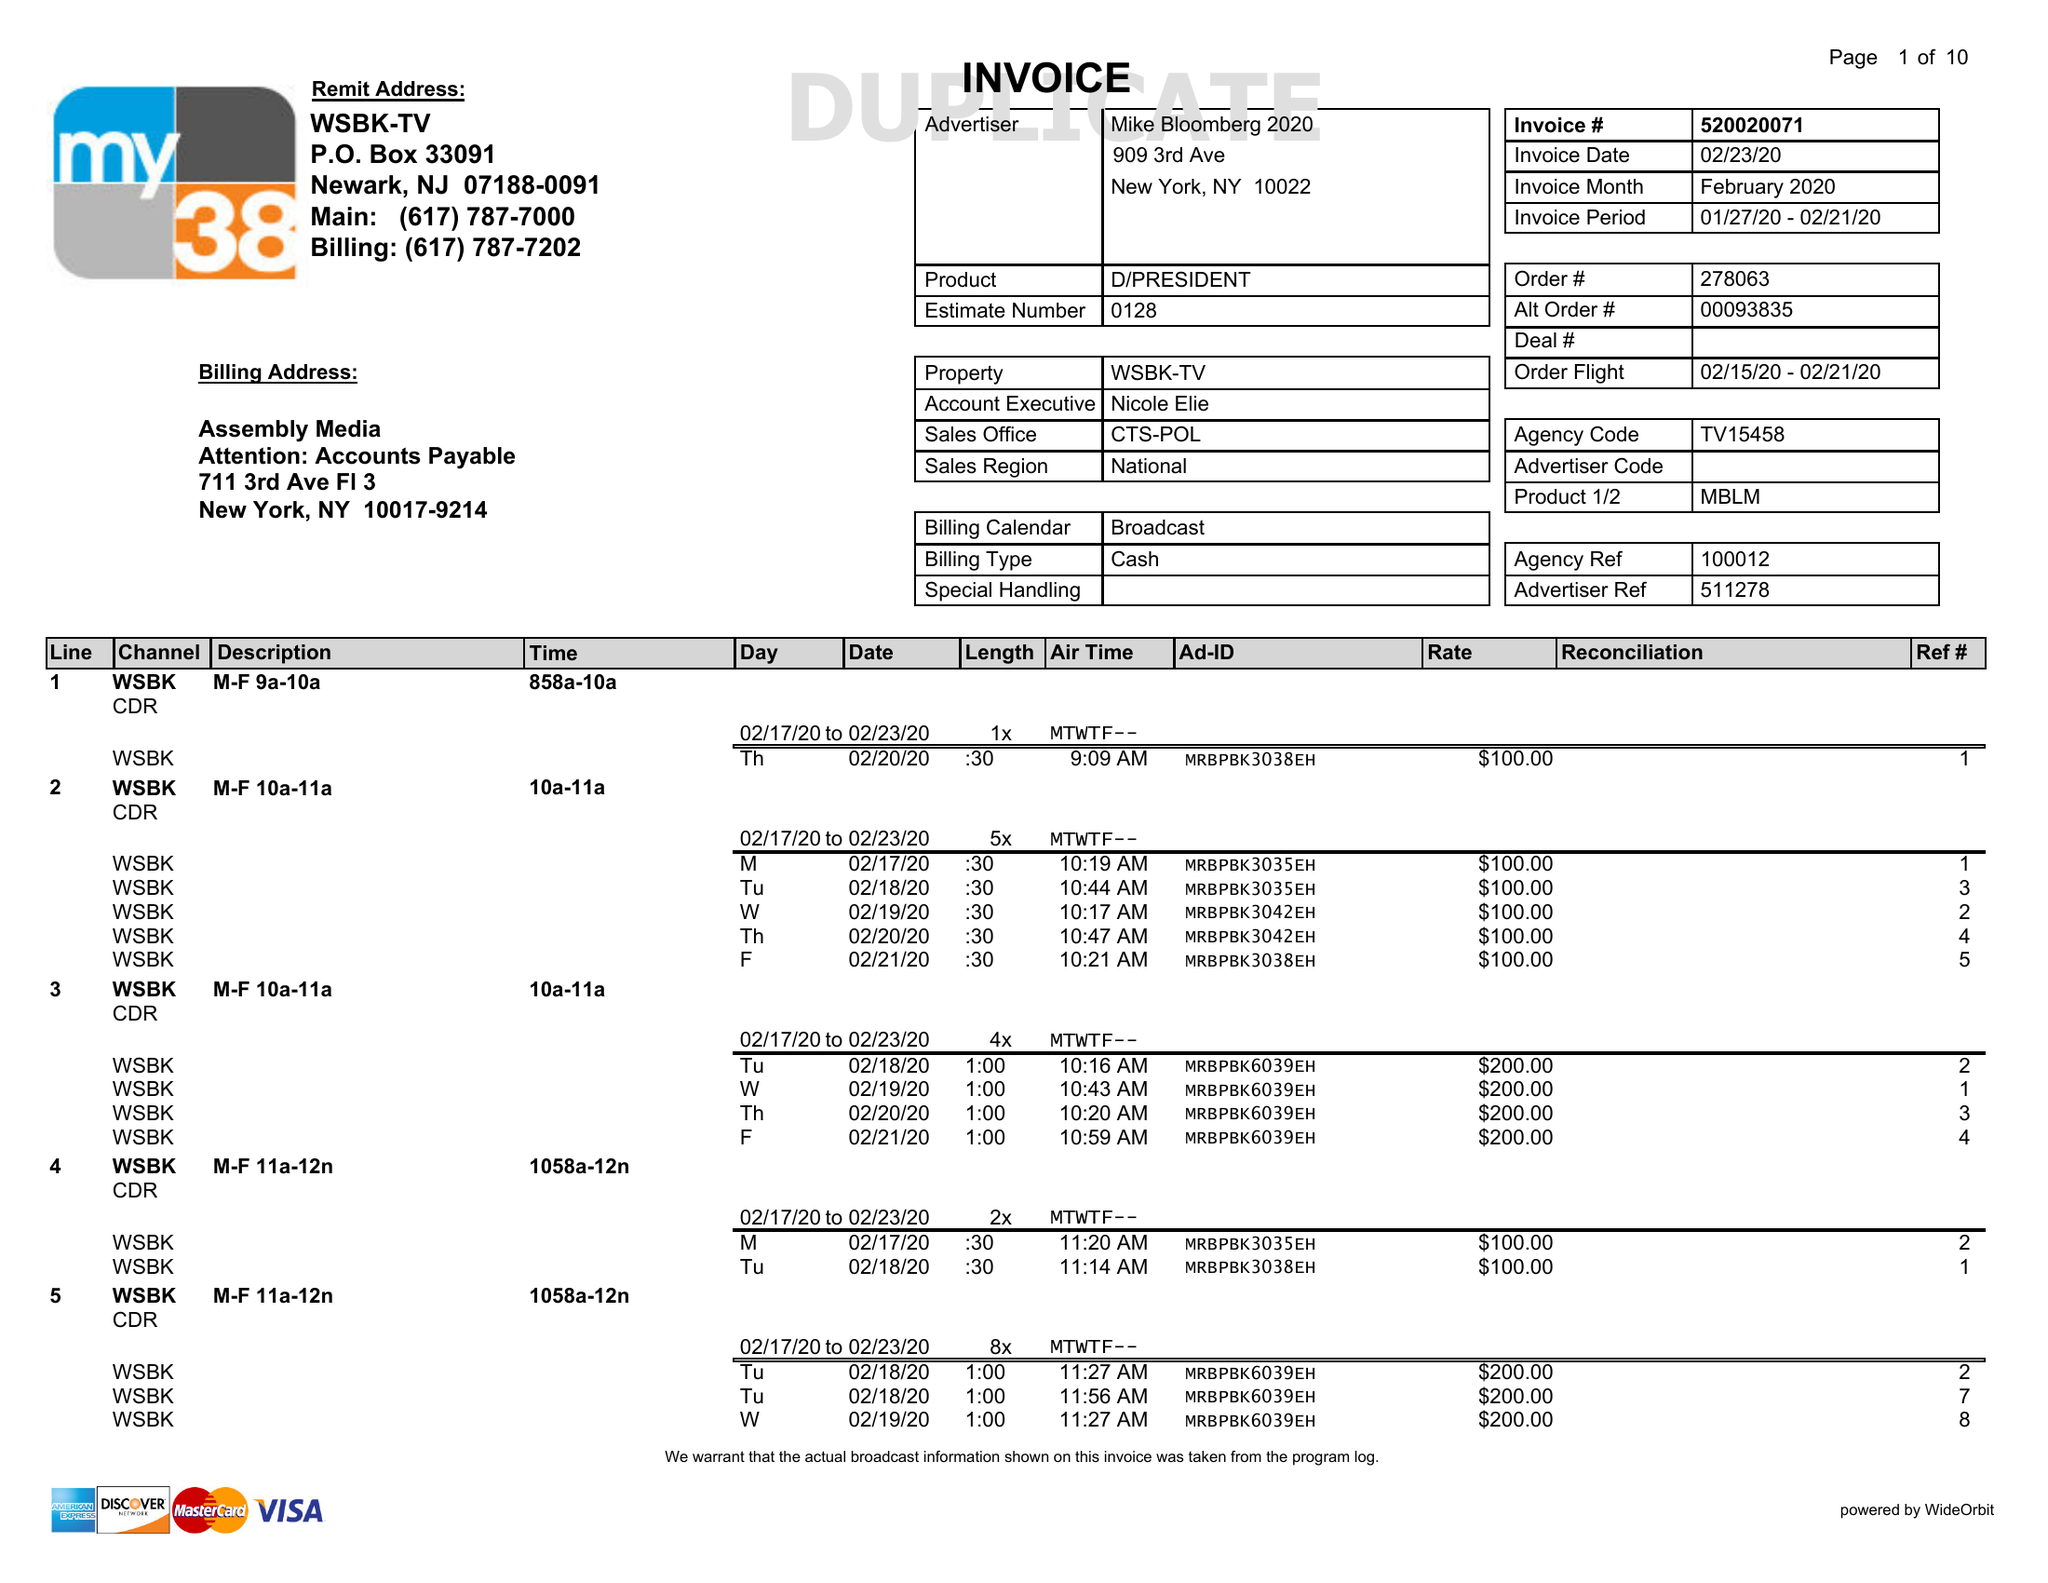What is the value for the advertiser?
Answer the question using a single word or phrase. MIKE BLOOMBERG 2020 